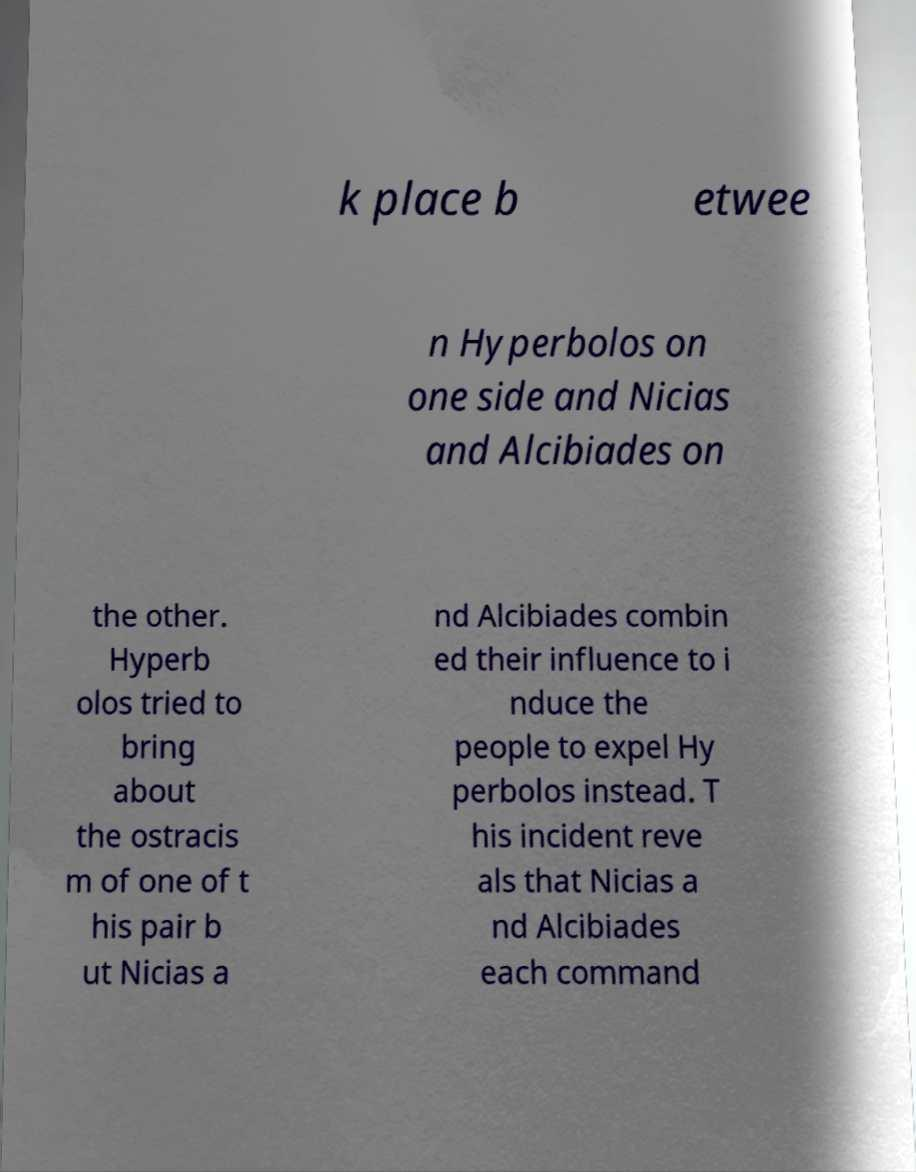There's text embedded in this image that I need extracted. Can you transcribe it verbatim? k place b etwee n Hyperbolos on one side and Nicias and Alcibiades on the other. Hyperb olos tried to bring about the ostracis m of one of t his pair b ut Nicias a nd Alcibiades combin ed their influence to i nduce the people to expel Hy perbolos instead. T his incident reve als that Nicias a nd Alcibiades each command 